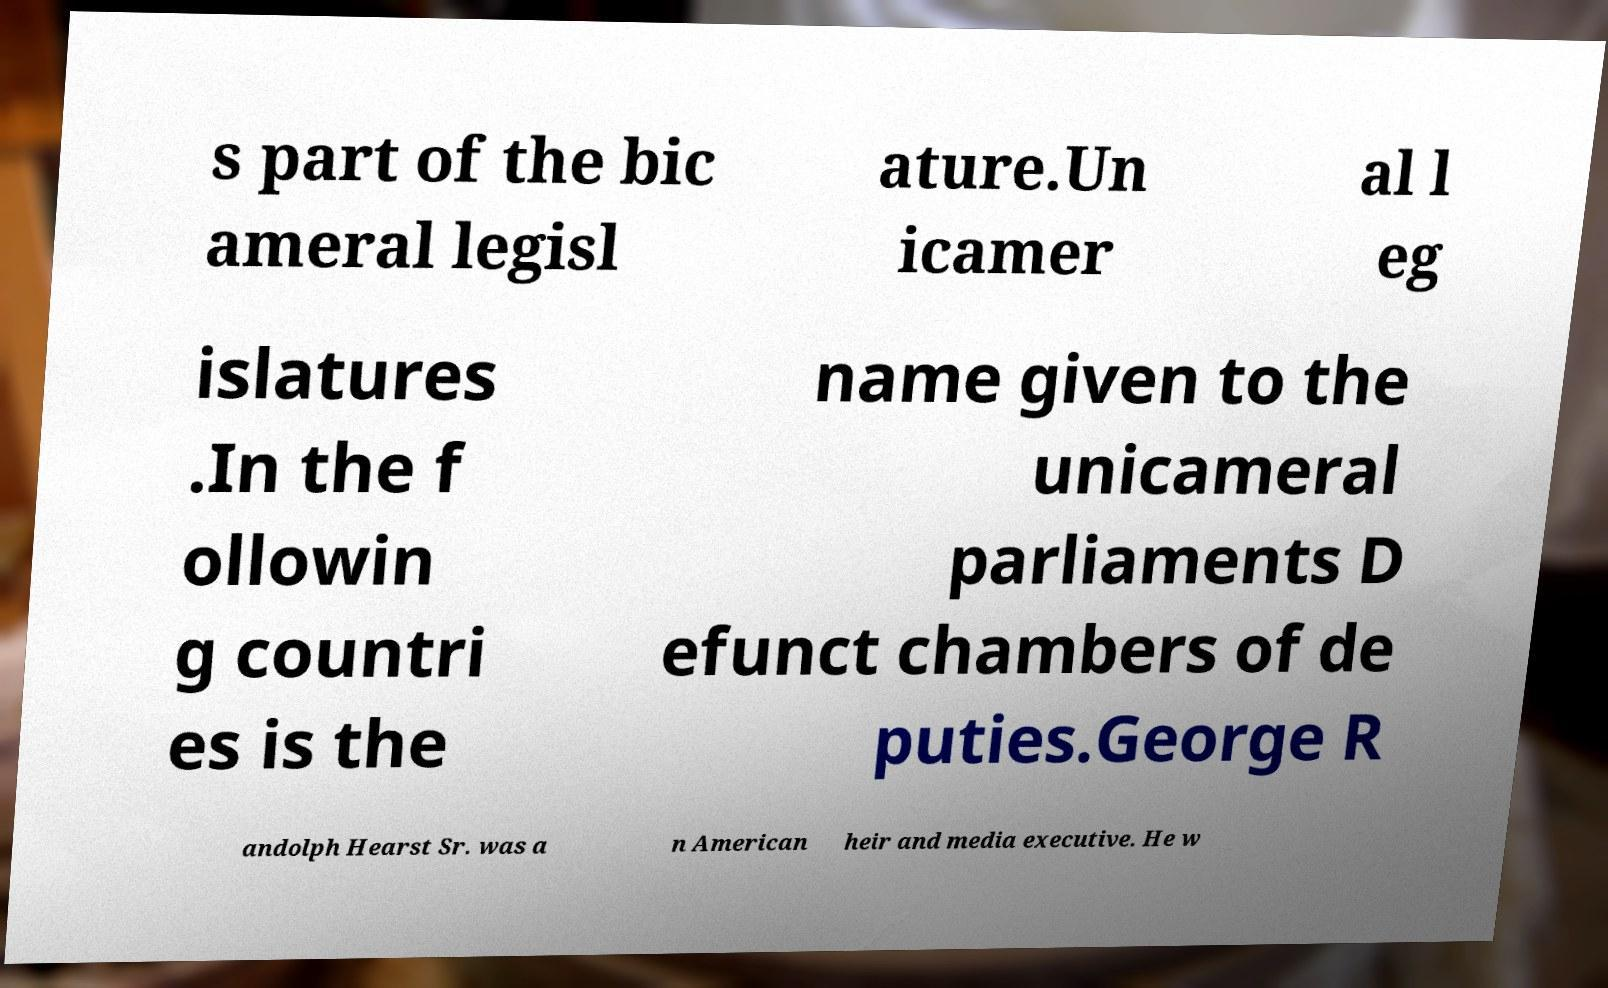Can you read and provide the text displayed in the image?This photo seems to have some interesting text. Can you extract and type it out for me? s part of the bic ameral legisl ature.Un icamer al l eg islatures .In the f ollowin g countri es is the name given to the unicameral parliaments D efunct chambers of de puties.George R andolph Hearst Sr. was a n American heir and media executive. He w 